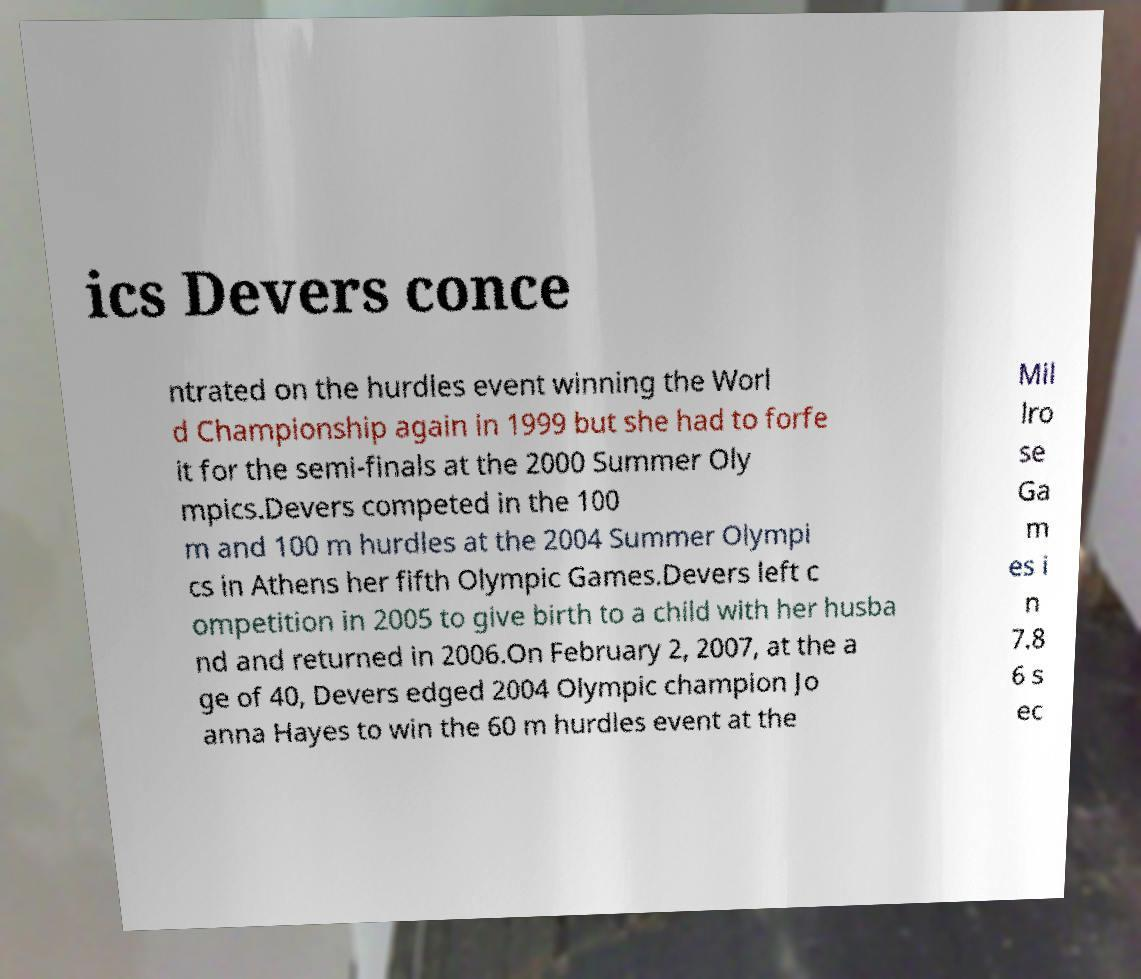I need the written content from this picture converted into text. Can you do that? ics Devers conce ntrated on the hurdles event winning the Worl d Championship again in 1999 but she had to forfe it for the semi-finals at the 2000 Summer Oly mpics.Devers competed in the 100 m and 100 m hurdles at the 2004 Summer Olympi cs in Athens her fifth Olympic Games.Devers left c ompetition in 2005 to give birth to a child with her husba nd and returned in 2006.On February 2, 2007, at the a ge of 40, Devers edged 2004 Olympic champion Jo anna Hayes to win the 60 m hurdles event at the Mil lro se Ga m es i n 7.8 6 s ec 